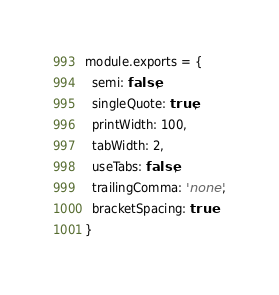Convert code to text. <code><loc_0><loc_0><loc_500><loc_500><_JavaScript_>module.exports = {
  semi: false,
  singleQuote: true,
  printWidth: 100,
  tabWidth: 2,
  useTabs: false,
  trailingComma: 'none',
  bracketSpacing: true
}
</code> 